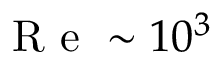<formula> <loc_0><loc_0><loc_500><loc_500>R e \sim 1 0 ^ { 3 }</formula> 